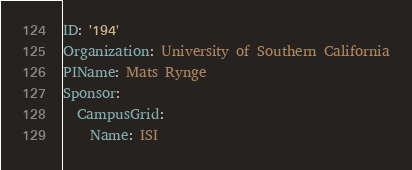<code> <loc_0><loc_0><loc_500><loc_500><_YAML_>ID: '194'
Organization: University of Southern California
PIName: Mats Rynge
Sponsor:
  CampusGrid:
    Name: ISI
</code> 